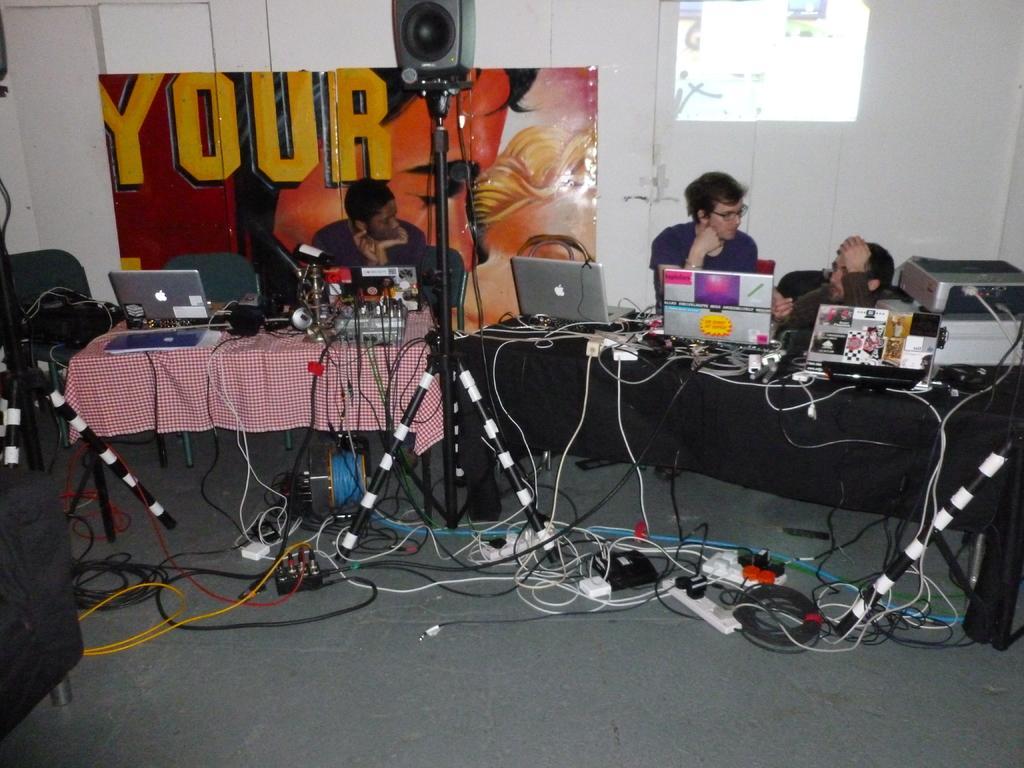In one or two sentences, can you explain what this image depicts? In this image there are some tables in the middle of this image. There are some laptops and other objects are kept on to it. There is one person on the left side of this image and there are two persons sitting on the right side of this image. There is a wall in the background. There are some objects kept on the floor as we can see in the bottom of this image. 